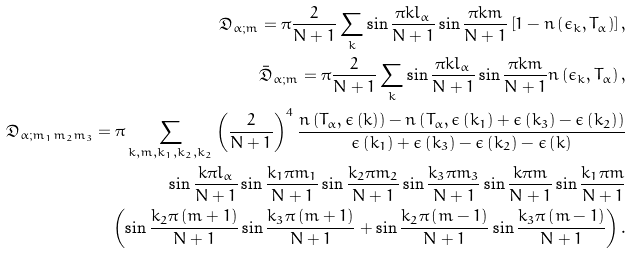Convert formula to latex. <formula><loc_0><loc_0><loc_500><loc_500>\mathfrak { D } _ { \alpha ; m } = \pi \frac { 2 } { N + 1 } \sum _ { k } \sin { \frac { \pi k l _ { \alpha } } { N + 1 } } \sin { \frac { \pi k m } { N + 1 } } \left [ 1 - n \left ( \epsilon _ { k } , T _ { \alpha } \right ) \right ] , \\ \mathfrak { \bar { D } } _ { \alpha ; m } = \pi \frac { 2 } { N + 1 } \sum _ { k } \sin { \frac { \pi k l _ { \alpha } } { N + 1 } } \sin { \frac { \pi k m } { N + 1 } } n \left ( \epsilon _ { k } , T _ { \alpha } \right ) , \\ \mathfrak { D } _ { \alpha ; m _ { 1 } m _ { 2 } m _ { 3 } } = \pi \sum _ { k , m , k _ { 1 } , k _ { 2 } , k _ { 2 } } \left ( \frac { 2 } { N + 1 } \right ) ^ { 4 } \frac { n \left ( T _ { \alpha } , \epsilon \left ( k \right ) \right ) - n \left ( T _ { \alpha } , \epsilon \left ( k _ { 1 } \right ) + \epsilon \left ( k _ { 3 } \right ) - \epsilon \left ( k _ { 2 } \right ) \right ) } { \epsilon \left ( k _ { 1 } \right ) + \epsilon \left ( k _ { 3 } \right ) - \epsilon \left ( k _ { 2 } \right ) - \epsilon \left ( k \right ) } \\ \sin { \frac { k \pi l _ { \alpha } } { N + 1 } } \sin { \frac { k _ { 1 } \pi m _ { 1 } } { N + 1 } } \sin { \frac { k _ { 2 } \pi m _ { 2 } } { N + 1 } } \sin { \frac { k _ { 3 } \pi m _ { 3 } } { N + 1 } } \sin { \frac { k \pi m } { N + 1 } } \sin { \frac { k _ { 1 } \pi m } { N + 1 } } \\ \left ( \sin { \frac { k _ { 2 } \pi \left ( m + 1 \right ) } { N + 1 } } \sin { \frac { k _ { 3 } \pi \left ( m + 1 \right ) } { N + 1 } } + \sin { \frac { k _ { 2 } \pi \left ( m - 1 \right ) } { N + 1 } } \sin { \frac { k _ { 3 } \pi \left ( m - 1 \right ) } { N + 1 } } \right ) .</formula> 